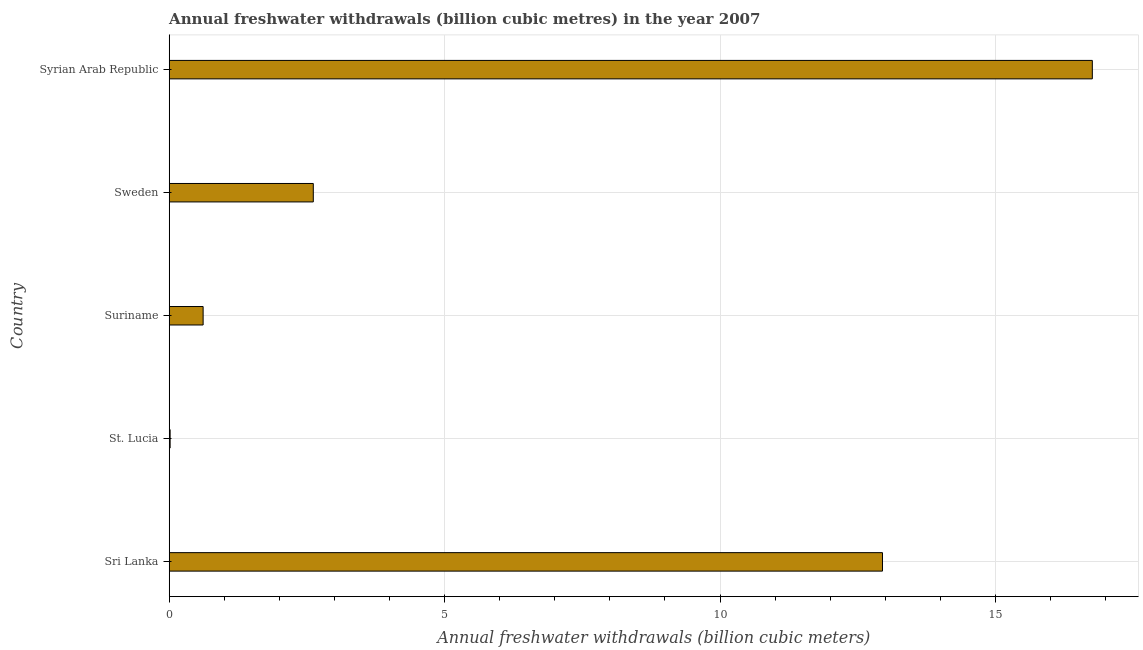Does the graph contain any zero values?
Keep it short and to the point. No. What is the title of the graph?
Your response must be concise. Annual freshwater withdrawals (billion cubic metres) in the year 2007. What is the label or title of the X-axis?
Provide a short and direct response. Annual freshwater withdrawals (billion cubic meters). What is the annual freshwater withdrawals in Sri Lanka?
Give a very brief answer. 12.95. Across all countries, what is the maximum annual freshwater withdrawals?
Give a very brief answer. 16.76. Across all countries, what is the minimum annual freshwater withdrawals?
Keep it short and to the point. 0.02. In which country was the annual freshwater withdrawals maximum?
Make the answer very short. Syrian Arab Republic. In which country was the annual freshwater withdrawals minimum?
Make the answer very short. St. Lucia. What is the sum of the annual freshwater withdrawals?
Ensure brevity in your answer.  32.96. What is the difference between the annual freshwater withdrawals in St. Lucia and Sweden?
Provide a short and direct response. -2.6. What is the average annual freshwater withdrawals per country?
Keep it short and to the point. 6.59. What is the median annual freshwater withdrawals?
Offer a very short reply. 2.62. What is the ratio of the annual freshwater withdrawals in Suriname to that in Syrian Arab Republic?
Offer a terse response. 0.04. Is the annual freshwater withdrawals in Sri Lanka less than that in Sweden?
Your response must be concise. No. Is the difference between the annual freshwater withdrawals in Sri Lanka and St. Lucia greater than the difference between any two countries?
Provide a succinct answer. No. What is the difference between the highest and the second highest annual freshwater withdrawals?
Your response must be concise. 3.81. What is the difference between the highest and the lowest annual freshwater withdrawals?
Make the answer very short. 16.74. In how many countries, is the annual freshwater withdrawals greater than the average annual freshwater withdrawals taken over all countries?
Your answer should be compact. 2. How many countries are there in the graph?
Your answer should be very brief. 5. What is the difference between two consecutive major ticks on the X-axis?
Keep it short and to the point. 5. Are the values on the major ticks of X-axis written in scientific E-notation?
Keep it short and to the point. No. What is the Annual freshwater withdrawals (billion cubic meters) in Sri Lanka?
Provide a short and direct response. 12.95. What is the Annual freshwater withdrawals (billion cubic meters) in St. Lucia?
Make the answer very short. 0.02. What is the Annual freshwater withdrawals (billion cubic meters) of Suriname?
Offer a terse response. 0.62. What is the Annual freshwater withdrawals (billion cubic meters) of Sweden?
Offer a terse response. 2.62. What is the Annual freshwater withdrawals (billion cubic meters) of Syrian Arab Republic?
Your answer should be compact. 16.76. What is the difference between the Annual freshwater withdrawals (billion cubic meters) in Sri Lanka and St. Lucia?
Ensure brevity in your answer.  12.93. What is the difference between the Annual freshwater withdrawals (billion cubic meters) in Sri Lanka and Suriname?
Your answer should be very brief. 12.33. What is the difference between the Annual freshwater withdrawals (billion cubic meters) in Sri Lanka and Sweden?
Keep it short and to the point. 10.33. What is the difference between the Annual freshwater withdrawals (billion cubic meters) in Sri Lanka and Syrian Arab Republic?
Offer a terse response. -3.81. What is the difference between the Annual freshwater withdrawals (billion cubic meters) in St. Lucia and Suriname?
Your answer should be very brief. -0.6. What is the difference between the Annual freshwater withdrawals (billion cubic meters) in St. Lucia and Sweden?
Your response must be concise. -2.6. What is the difference between the Annual freshwater withdrawals (billion cubic meters) in St. Lucia and Syrian Arab Republic?
Your response must be concise. -16.74. What is the difference between the Annual freshwater withdrawals (billion cubic meters) in Suriname and Sweden?
Offer a very short reply. -2. What is the difference between the Annual freshwater withdrawals (billion cubic meters) in Suriname and Syrian Arab Republic?
Make the answer very short. -16.14. What is the difference between the Annual freshwater withdrawals (billion cubic meters) in Sweden and Syrian Arab Republic?
Provide a succinct answer. -14.14. What is the ratio of the Annual freshwater withdrawals (billion cubic meters) in Sri Lanka to that in St. Lucia?
Keep it short and to the point. 780.12. What is the ratio of the Annual freshwater withdrawals (billion cubic meters) in Sri Lanka to that in Suriname?
Make the answer very short. 21.03. What is the ratio of the Annual freshwater withdrawals (billion cubic meters) in Sri Lanka to that in Sweden?
Make the answer very short. 4.95. What is the ratio of the Annual freshwater withdrawals (billion cubic meters) in Sri Lanka to that in Syrian Arab Republic?
Give a very brief answer. 0.77. What is the ratio of the Annual freshwater withdrawals (billion cubic meters) in St. Lucia to that in Suriname?
Give a very brief answer. 0.03. What is the ratio of the Annual freshwater withdrawals (billion cubic meters) in St. Lucia to that in Sweden?
Your response must be concise. 0.01. What is the ratio of the Annual freshwater withdrawals (billion cubic meters) in Suriname to that in Sweden?
Ensure brevity in your answer.  0.23. What is the ratio of the Annual freshwater withdrawals (billion cubic meters) in Suriname to that in Syrian Arab Republic?
Ensure brevity in your answer.  0.04. What is the ratio of the Annual freshwater withdrawals (billion cubic meters) in Sweden to that in Syrian Arab Republic?
Your response must be concise. 0.16. 